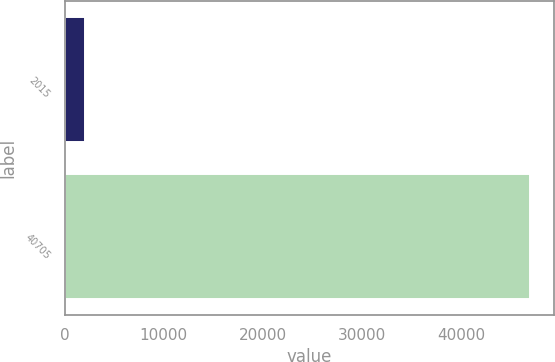<chart> <loc_0><loc_0><loc_500><loc_500><bar_chart><fcel>2015<fcel>40705<nl><fcel>2014<fcel>47022<nl></chart> 